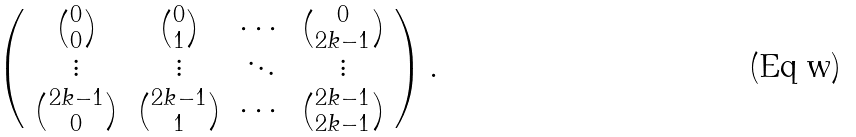Convert formula to latex. <formula><loc_0><loc_0><loc_500><loc_500>\left ( \begin{array} { c c c c c c c c c c c c } \binom { 0 } { 0 } & \binom { 0 } { 1 } & \cdots & \binom { 0 } { 2 k - 1 } \\ \vdots & \vdots & \ddots & \vdots \\ \binom { 2 k - 1 } { 0 } & \binom { 2 k - 1 } { 1 } & \cdots & \binom { 2 k - 1 } { 2 k - 1 } \end{array} \right ) .</formula> 